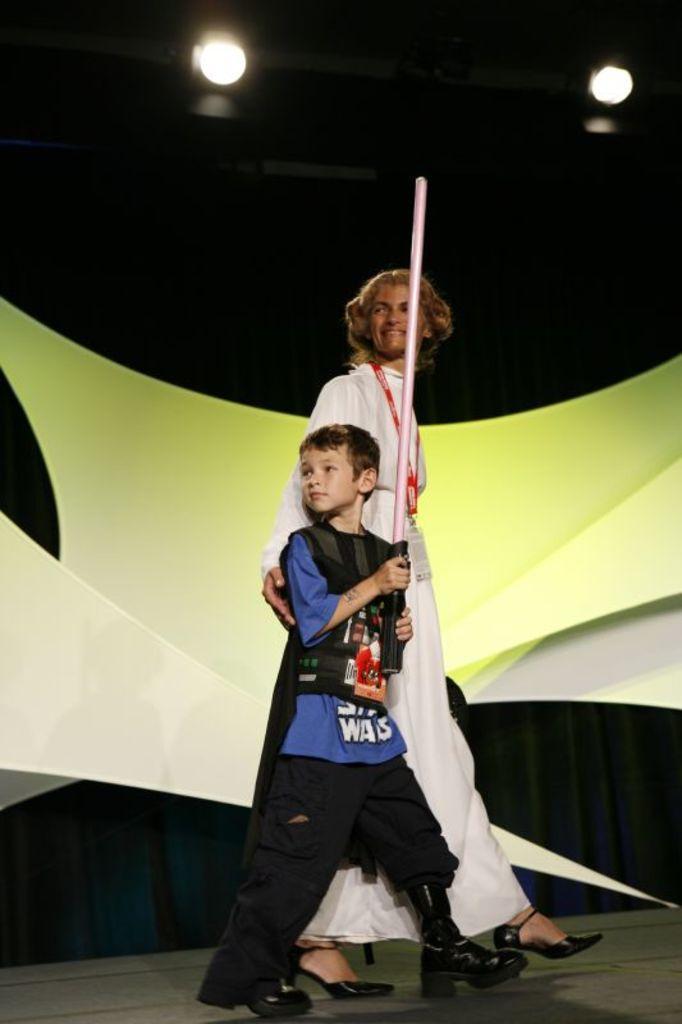Could you give a brief overview of what you see in this image? This picture seems to be clicked inside. In the foreground there is a kid holding an object and a person walking on the ground. In the background there is an object and we can see the focusing lights and the curtains. 